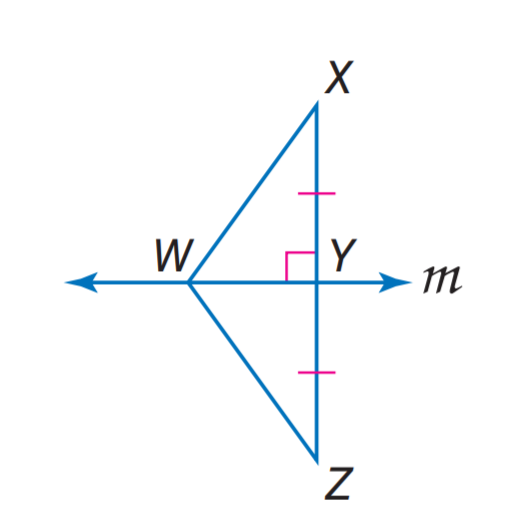Answer the mathemtical geometry problem and directly provide the correct option letter.
Question: If W Z = 25.3, Y Z = 22.4, W Z = 25.3, find X Y.
Choices: A: 14.9 B: 21 C: 22.4 D: 25.3 C 